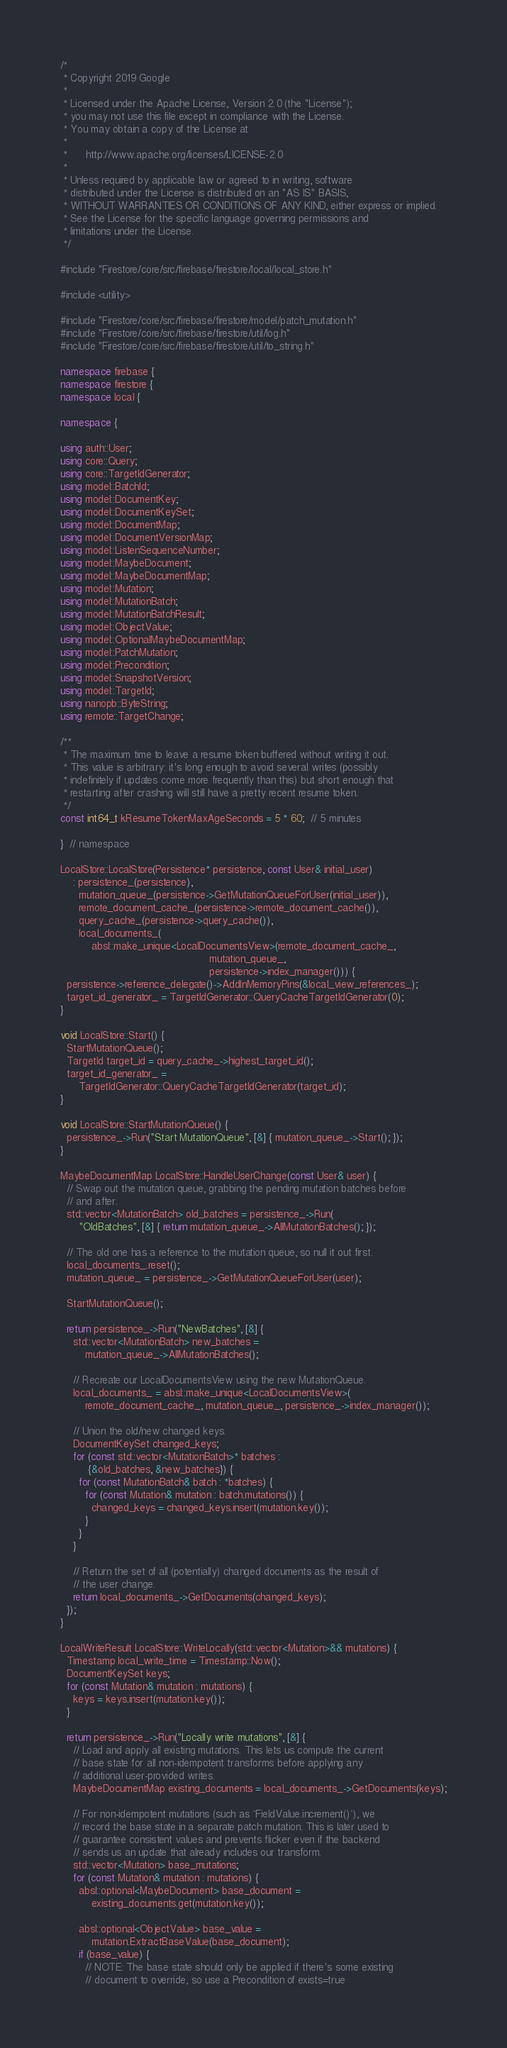Convert code to text. <code><loc_0><loc_0><loc_500><loc_500><_C++_>/*
 * Copyright 2019 Google
 *
 * Licensed under the Apache License, Version 2.0 (the "License");
 * you may not use this file except in compliance with the License.
 * You may obtain a copy of the License at
 *
 *      http://www.apache.org/licenses/LICENSE-2.0
 *
 * Unless required by applicable law or agreed to in writing, software
 * distributed under the License is distributed on an "AS IS" BASIS,
 * WITHOUT WARRANTIES OR CONDITIONS OF ANY KIND, either express or implied.
 * See the License for the specific language governing permissions and
 * limitations under the License.
 */

#include "Firestore/core/src/firebase/firestore/local/local_store.h"

#include <utility>

#include "Firestore/core/src/firebase/firestore/model/patch_mutation.h"
#include "Firestore/core/src/firebase/firestore/util/log.h"
#include "Firestore/core/src/firebase/firestore/util/to_string.h"

namespace firebase {
namespace firestore {
namespace local {

namespace {

using auth::User;
using core::Query;
using core::TargetIdGenerator;
using model::BatchId;
using model::DocumentKey;
using model::DocumentKeySet;
using model::DocumentMap;
using model::DocumentVersionMap;
using model::ListenSequenceNumber;
using model::MaybeDocument;
using model::MaybeDocumentMap;
using model::Mutation;
using model::MutationBatch;
using model::MutationBatchResult;
using model::ObjectValue;
using model::OptionalMaybeDocumentMap;
using model::PatchMutation;
using model::Precondition;
using model::SnapshotVersion;
using model::TargetId;
using nanopb::ByteString;
using remote::TargetChange;

/**
 * The maximum time to leave a resume token buffered without writing it out.
 * This value is arbitrary: it's long enough to avoid several writes (possibly
 * indefinitely if updates come more frequently than this) but short enough that
 * restarting after crashing will still have a pretty recent resume token.
 */
const int64_t kResumeTokenMaxAgeSeconds = 5 * 60;  // 5 minutes

}  // namespace

LocalStore::LocalStore(Persistence* persistence, const User& initial_user)
    : persistence_(persistence),
      mutation_queue_(persistence->GetMutationQueueForUser(initial_user)),
      remote_document_cache_(persistence->remote_document_cache()),
      query_cache_(persistence->query_cache()),
      local_documents_(
          absl::make_unique<LocalDocumentsView>(remote_document_cache_,
                                                mutation_queue_,
                                                persistence->index_manager())) {
  persistence->reference_delegate()->AddInMemoryPins(&local_view_references_);
  target_id_generator_ = TargetIdGenerator::QueryCacheTargetIdGenerator(0);
}

void LocalStore::Start() {
  StartMutationQueue();
  TargetId target_id = query_cache_->highest_target_id();
  target_id_generator_ =
      TargetIdGenerator::QueryCacheTargetIdGenerator(target_id);
}

void LocalStore::StartMutationQueue() {
  persistence_->Run("Start MutationQueue", [&] { mutation_queue_->Start(); });
}

MaybeDocumentMap LocalStore::HandleUserChange(const User& user) {
  // Swap out the mutation queue, grabbing the pending mutation batches before
  // and after.
  std::vector<MutationBatch> old_batches = persistence_->Run(
      "OldBatches", [&] { return mutation_queue_->AllMutationBatches(); });

  // The old one has a reference to the mutation queue, so null it out first.
  local_documents_.reset();
  mutation_queue_ = persistence_->GetMutationQueueForUser(user);

  StartMutationQueue();

  return persistence_->Run("NewBatches", [&] {
    std::vector<MutationBatch> new_batches =
        mutation_queue_->AllMutationBatches();

    // Recreate our LocalDocumentsView using the new MutationQueue.
    local_documents_ = absl::make_unique<LocalDocumentsView>(
        remote_document_cache_, mutation_queue_, persistence_->index_manager());

    // Union the old/new changed keys.
    DocumentKeySet changed_keys;
    for (const std::vector<MutationBatch>* batches :
         {&old_batches, &new_batches}) {
      for (const MutationBatch& batch : *batches) {
        for (const Mutation& mutation : batch.mutations()) {
          changed_keys = changed_keys.insert(mutation.key());
        }
      }
    }

    // Return the set of all (potentially) changed documents as the result of
    // the user change.
    return local_documents_->GetDocuments(changed_keys);
  });
}

LocalWriteResult LocalStore::WriteLocally(std::vector<Mutation>&& mutations) {
  Timestamp local_write_time = Timestamp::Now();
  DocumentKeySet keys;
  for (const Mutation& mutation : mutations) {
    keys = keys.insert(mutation.key());
  }

  return persistence_->Run("Locally write mutations", [&] {
    // Load and apply all existing mutations. This lets us compute the current
    // base state for all non-idempotent transforms before applying any
    // additional user-provided writes.
    MaybeDocumentMap existing_documents = local_documents_->GetDocuments(keys);

    // For non-idempotent mutations (such as `FieldValue.increment()`), we
    // record the base state in a separate patch mutation. This is later used to
    // guarantee consistent values and prevents flicker even if the backend
    // sends us an update that already includes our transform.
    std::vector<Mutation> base_mutations;
    for (const Mutation& mutation : mutations) {
      absl::optional<MaybeDocument> base_document =
          existing_documents.get(mutation.key());

      absl::optional<ObjectValue> base_value =
          mutation.ExtractBaseValue(base_document);
      if (base_value) {
        // NOTE: The base state should only be applied if there's some existing
        // document to override, so use a Precondition of exists=true</code> 